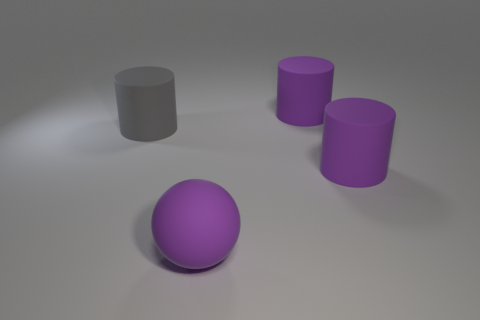There is a ball; is its color the same as the large cylinder that is in front of the gray matte cylinder?
Provide a short and direct response. Yes. Are there fewer large purple cylinders than large objects?
Your response must be concise. Yes. What color is the big object that is both behind the ball and in front of the gray matte thing?
Provide a succinct answer. Purple. Is there any other thing that has the same size as the gray matte object?
Give a very brief answer. Yes. Are there more large matte objects than matte spheres?
Offer a terse response. Yes. What is the size of the purple object that is in front of the big gray rubber object and on the right side of the purple matte sphere?
Provide a succinct answer. Large. What number of other big gray rubber things have the same shape as the gray rubber thing?
Your answer should be very brief. 0. Are there fewer big rubber objects that are to the left of the big sphere than big gray matte cylinders on the left side of the gray matte object?
Make the answer very short. No. There is a large rubber cylinder on the left side of the big sphere; how many big purple matte things are in front of it?
Offer a very short reply. 2. Are any spheres visible?
Ensure brevity in your answer.  Yes. 